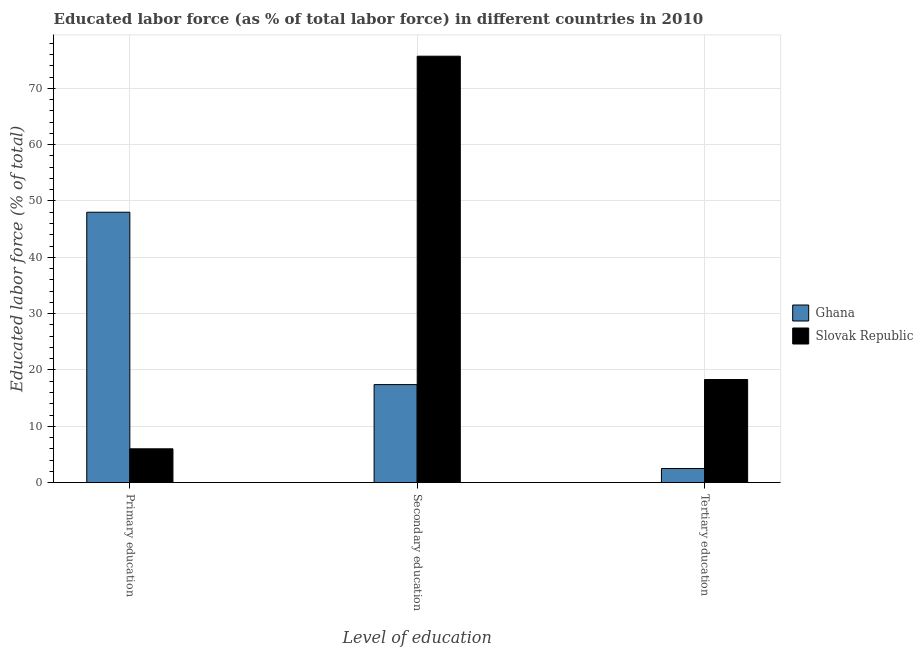How many different coloured bars are there?
Offer a terse response. 2. How many bars are there on the 1st tick from the right?
Offer a very short reply. 2. What is the label of the 3rd group of bars from the left?
Your answer should be compact. Tertiary education. Across all countries, what is the maximum percentage of labor force who received primary education?
Keep it short and to the point. 48. In which country was the percentage of labor force who received tertiary education maximum?
Your answer should be compact. Slovak Republic. In which country was the percentage of labor force who received primary education minimum?
Your answer should be compact. Slovak Republic. What is the total percentage of labor force who received secondary education in the graph?
Ensure brevity in your answer.  93.1. What is the difference between the percentage of labor force who received primary education in Slovak Republic and the percentage of labor force who received tertiary education in Ghana?
Make the answer very short. 3.5. What is the average percentage of labor force who received secondary education per country?
Provide a short and direct response. 46.55. What is the difference between the percentage of labor force who received secondary education and percentage of labor force who received primary education in Slovak Republic?
Provide a short and direct response. 69.7. In how many countries, is the percentage of labor force who received primary education greater than 10 %?
Make the answer very short. 1. What is the ratio of the percentage of labor force who received tertiary education in Slovak Republic to that in Ghana?
Keep it short and to the point. 7.32. Is the percentage of labor force who received tertiary education in Ghana less than that in Slovak Republic?
Make the answer very short. Yes. What is the difference between the highest and the second highest percentage of labor force who received tertiary education?
Your response must be concise. 15.8. What is the difference between the highest and the lowest percentage of labor force who received primary education?
Keep it short and to the point. 42. What does the 2nd bar from the left in Primary education represents?
Give a very brief answer. Slovak Republic. How many countries are there in the graph?
Your response must be concise. 2. What is the difference between two consecutive major ticks on the Y-axis?
Make the answer very short. 10. Are the values on the major ticks of Y-axis written in scientific E-notation?
Your response must be concise. No. Does the graph contain any zero values?
Make the answer very short. No. Does the graph contain grids?
Keep it short and to the point. Yes. Where does the legend appear in the graph?
Your answer should be compact. Center right. How many legend labels are there?
Make the answer very short. 2. How are the legend labels stacked?
Provide a succinct answer. Vertical. What is the title of the graph?
Offer a terse response. Educated labor force (as % of total labor force) in different countries in 2010. What is the label or title of the X-axis?
Offer a terse response. Level of education. What is the label or title of the Y-axis?
Ensure brevity in your answer.  Educated labor force (% of total). What is the Educated labor force (% of total) in Ghana in Primary education?
Your answer should be very brief. 48. What is the Educated labor force (% of total) of Ghana in Secondary education?
Your response must be concise. 17.4. What is the Educated labor force (% of total) in Slovak Republic in Secondary education?
Provide a succinct answer. 75.7. What is the Educated labor force (% of total) in Ghana in Tertiary education?
Offer a very short reply. 2.5. What is the Educated labor force (% of total) in Slovak Republic in Tertiary education?
Your answer should be very brief. 18.3. Across all Level of education, what is the maximum Educated labor force (% of total) of Ghana?
Provide a succinct answer. 48. Across all Level of education, what is the maximum Educated labor force (% of total) of Slovak Republic?
Provide a succinct answer. 75.7. What is the total Educated labor force (% of total) in Ghana in the graph?
Give a very brief answer. 67.9. What is the total Educated labor force (% of total) in Slovak Republic in the graph?
Give a very brief answer. 100. What is the difference between the Educated labor force (% of total) of Ghana in Primary education and that in Secondary education?
Give a very brief answer. 30.6. What is the difference between the Educated labor force (% of total) of Slovak Republic in Primary education and that in Secondary education?
Your answer should be very brief. -69.7. What is the difference between the Educated labor force (% of total) of Ghana in Primary education and that in Tertiary education?
Provide a short and direct response. 45.5. What is the difference between the Educated labor force (% of total) of Slovak Republic in Primary education and that in Tertiary education?
Provide a succinct answer. -12.3. What is the difference between the Educated labor force (% of total) of Slovak Republic in Secondary education and that in Tertiary education?
Make the answer very short. 57.4. What is the difference between the Educated labor force (% of total) in Ghana in Primary education and the Educated labor force (% of total) in Slovak Republic in Secondary education?
Offer a terse response. -27.7. What is the difference between the Educated labor force (% of total) of Ghana in Primary education and the Educated labor force (% of total) of Slovak Republic in Tertiary education?
Your answer should be very brief. 29.7. What is the average Educated labor force (% of total) of Ghana per Level of education?
Your answer should be very brief. 22.63. What is the average Educated labor force (% of total) of Slovak Republic per Level of education?
Your answer should be very brief. 33.33. What is the difference between the Educated labor force (% of total) of Ghana and Educated labor force (% of total) of Slovak Republic in Secondary education?
Ensure brevity in your answer.  -58.3. What is the difference between the Educated labor force (% of total) of Ghana and Educated labor force (% of total) of Slovak Republic in Tertiary education?
Your answer should be compact. -15.8. What is the ratio of the Educated labor force (% of total) in Ghana in Primary education to that in Secondary education?
Provide a short and direct response. 2.76. What is the ratio of the Educated labor force (% of total) in Slovak Republic in Primary education to that in Secondary education?
Give a very brief answer. 0.08. What is the ratio of the Educated labor force (% of total) of Slovak Republic in Primary education to that in Tertiary education?
Ensure brevity in your answer.  0.33. What is the ratio of the Educated labor force (% of total) in Ghana in Secondary education to that in Tertiary education?
Your answer should be very brief. 6.96. What is the ratio of the Educated labor force (% of total) in Slovak Republic in Secondary education to that in Tertiary education?
Your answer should be compact. 4.14. What is the difference between the highest and the second highest Educated labor force (% of total) in Ghana?
Provide a succinct answer. 30.6. What is the difference between the highest and the second highest Educated labor force (% of total) in Slovak Republic?
Give a very brief answer. 57.4. What is the difference between the highest and the lowest Educated labor force (% of total) of Ghana?
Ensure brevity in your answer.  45.5. What is the difference between the highest and the lowest Educated labor force (% of total) in Slovak Republic?
Offer a terse response. 69.7. 